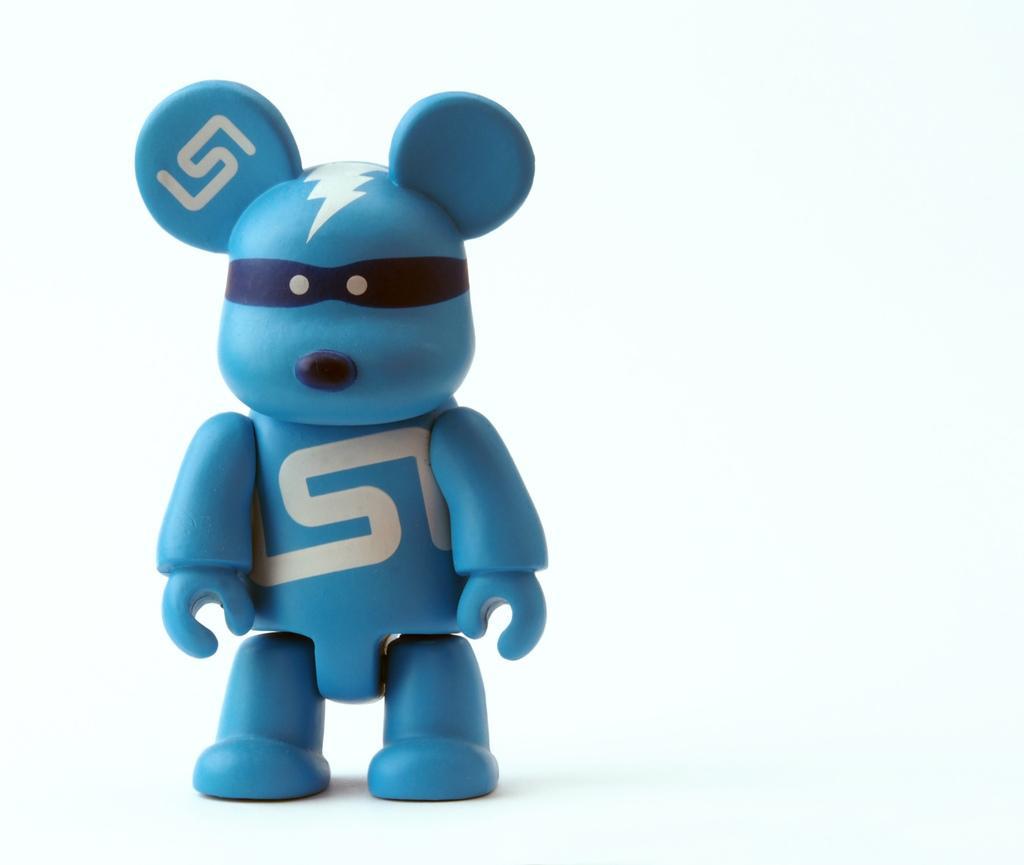How would you summarize this image in a sentence or two? In the picture I can see a blue color toy. The background of the image is white in color. 